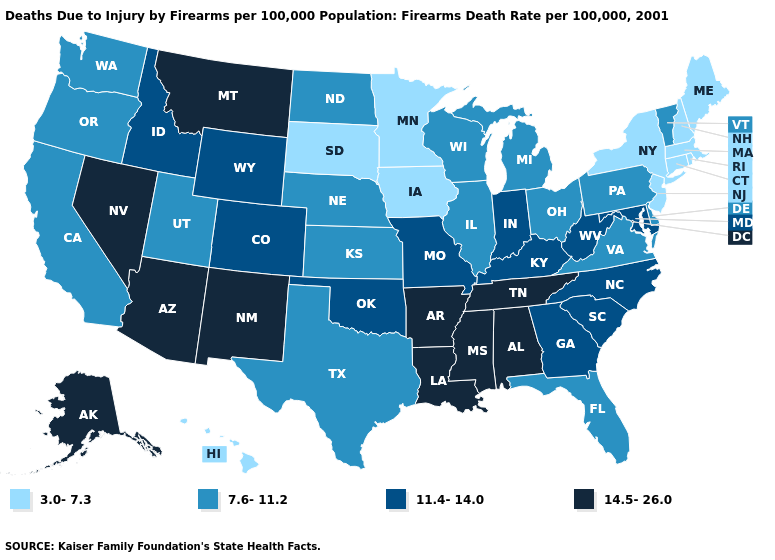Does Hawaii have the lowest value in the USA?
Give a very brief answer. Yes. Name the states that have a value in the range 14.5-26.0?
Give a very brief answer. Alabama, Alaska, Arizona, Arkansas, Louisiana, Mississippi, Montana, Nevada, New Mexico, Tennessee. Name the states that have a value in the range 7.6-11.2?
Concise answer only. California, Delaware, Florida, Illinois, Kansas, Michigan, Nebraska, North Dakota, Ohio, Oregon, Pennsylvania, Texas, Utah, Vermont, Virginia, Washington, Wisconsin. Which states have the lowest value in the USA?
Quick response, please. Connecticut, Hawaii, Iowa, Maine, Massachusetts, Minnesota, New Hampshire, New Jersey, New York, Rhode Island, South Dakota. Does Arizona have the highest value in the USA?
Write a very short answer. Yes. Does Maine have a lower value than Minnesota?
Write a very short answer. No. Name the states that have a value in the range 14.5-26.0?
Be succinct. Alabama, Alaska, Arizona, Arkansas, Louisiana, Mississippi, Montana, Nevada, New Mexico, Tennessee. Name the states that have a value in the range 7.6-11.2?
Short answer required. California, Delaware, Florida, Illinois, Kansas, Michigan, Nebraska, North Dakota, Ohio, Oregon, Pennsylvania, Texas, Utah, Vermont, Virginia, Washington, Wisconsin. Which states hav the highest value in the South?
Write a very short answer. Alabama, Arkansas, Louisiana, Mississippi, Tennessee. Among the states that border Oregon , which have the highest value?
Quick response, please. Nevada. Among the states that border Iowa , does Minnesota have the highest value?
Concise answer only. No. What is the highest value in states that border Massachusetts?
Quick response, please. 7.6-11.2. Name the states that have a value in the range 11.4-14.0?
Quick response, please. Colorado, Georgia, Idaho, Indiana, Kentucky, Maryland, Missouri, North Carolina, Oklahoma, South Carolina, West Virginia, Wyoming. What is the value of Vermont?
Concise answer only. 7.6-11.2. 